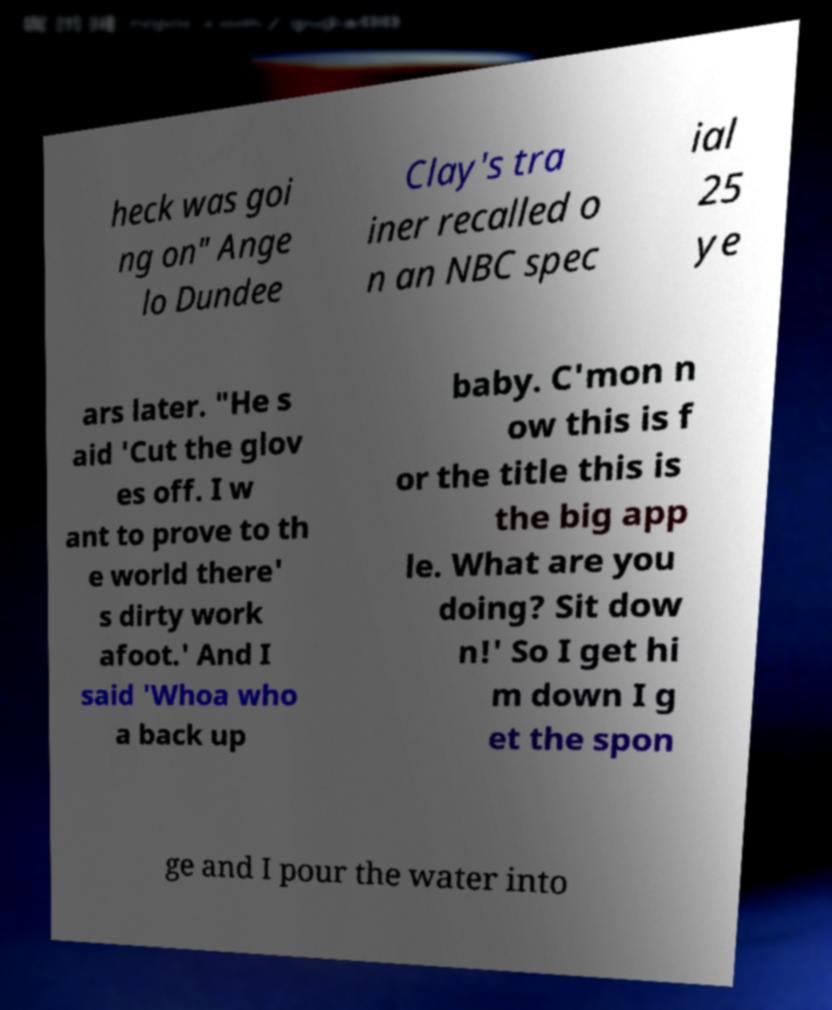Please read and relay the text visible in this image. What does it say? heck was goi ng on" Ange lo Dundee Clay's tra iner recalled o n an NBC spec ial 25 ye ars later. "He s aid 'Cut the glov es off. I w ant to prove to th e world there' s dirty work afoot.' And I said 'Whoa who a back up baby. C'mon n ow this is f or the title this is the big app le. What are you doing? Sit dow n!' So I get hi m down I g et the spon ge and I pour the water into 